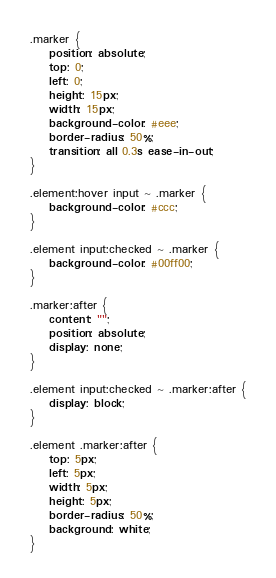Convert code to text. <code><loc_0><loc_0><loc_500><loc_500><_CSS_>.marker {
    position: absolute;
    top: 0;
    left: 0;
    height: 15px;
    width: 15px;
    background-color: #eee;
    border-radius: 50%;
    transition: all 0.3s ease-in-out;
}

.element:hover input ~ .marker {
    background-color: #ccc;
}

.element input:checked ~ .marker {
    background-color: #00ff00;
}

.marker:after {
    content: "";
    position: absolute;
    display: none;
}

.element input:checked ~ .marker:after {
    display: block;
}

.element .marker:after {
    top: 5px;
	left: 5px;
	width: 5px;
	height: 5px;
    border-radius: 50%;
    background: white;
}
</code> 